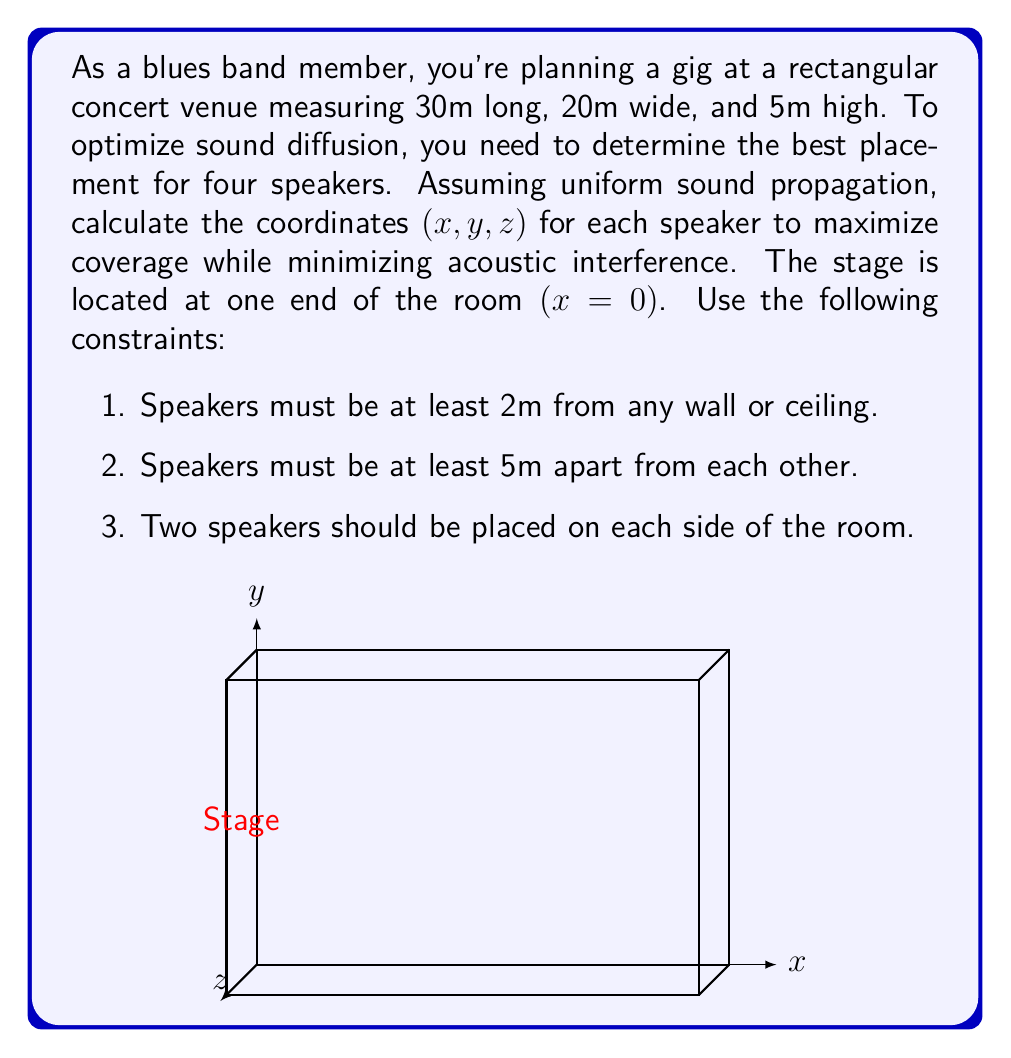Solve this math problem. To solve this problem, we'll follow these steps:

1) First, let's consider the constraints:
   - Speakers must be at least 2m from walls and ceiling, so the valid range for coordinates is:
     x: [2, 28], y: [2, 18], z: [2, 3]
   - Speakers must be at least 5m apart
   - Two speakers on each side of the room

2) To maximize coverage, we should place the speakers as far apart as possible while respecting the constraints. Let's start with the y-coordinate:
   - Two speakers at y = 2 (left side)
   - Two speakers at y = 18 (right side)

3) For the x-coordinate, we want to spread the speakers along the length of the room:
   - On each side, one speaker near the front and one near the back
   - Let's choose x = 7 for the front speakers and x = 23 for the back speakers

4) For the z-coordinate (height), we'll place all speakers at the same height to ensure consistent sound distribution. A good height would be:
   z = 3 (2m from the floor, which is typically above head height)

5) Now we have the coordinates for our four speakers:
   Speaker 1: (7, 2, 3)
   Speaker 2: (23, 2, 3)
   Speaker 3: (7, 18, 3)
   Speaker 4: (23, 18, 3)

6) Let's verify that these placements satisfy our constraints:
   - All speakers are at least 2m from walls and ceiling
   - The minimum distance between any two speakers is:
     $$\sqrt{(23-7)^2 + (18-2)^2 + (3-3)^2} = \sqrt{256 + 256 + 0} = \sqrt{512} \approx 22.6m > 5m$$
   - Two speakers are on each side of the room

Therefore, these coordinates provide an optimal placement for the four speakers to maximize sound diffusion in the concert venue.
Answer: Speaker coordinates: (7, 2, 3), (23, 2, 3), (7, 18, 3), (23, 18, 3) 